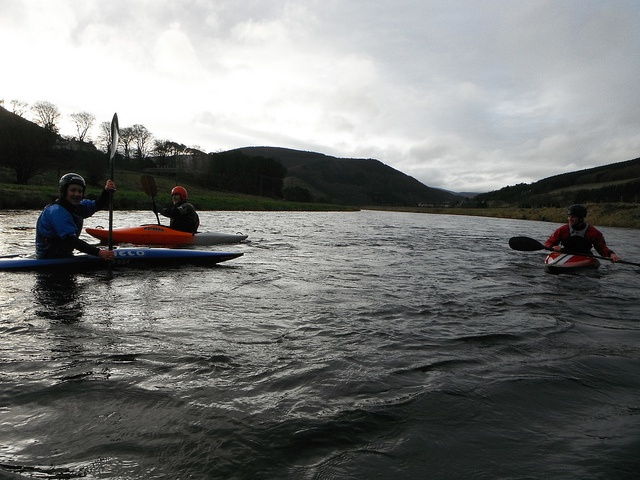Describe the objects in this image and their specific colors. I can see people in lightgray, black, navy, maroon, and gray tones, boat in lightgray, black, navy, gray, and darkgray tones, boat in lightgray, black, and maroon tones, people in lightgray, black, maroon, and gray tones, and people in lightgray, black, maroon, gray, and brown tones in this image. 